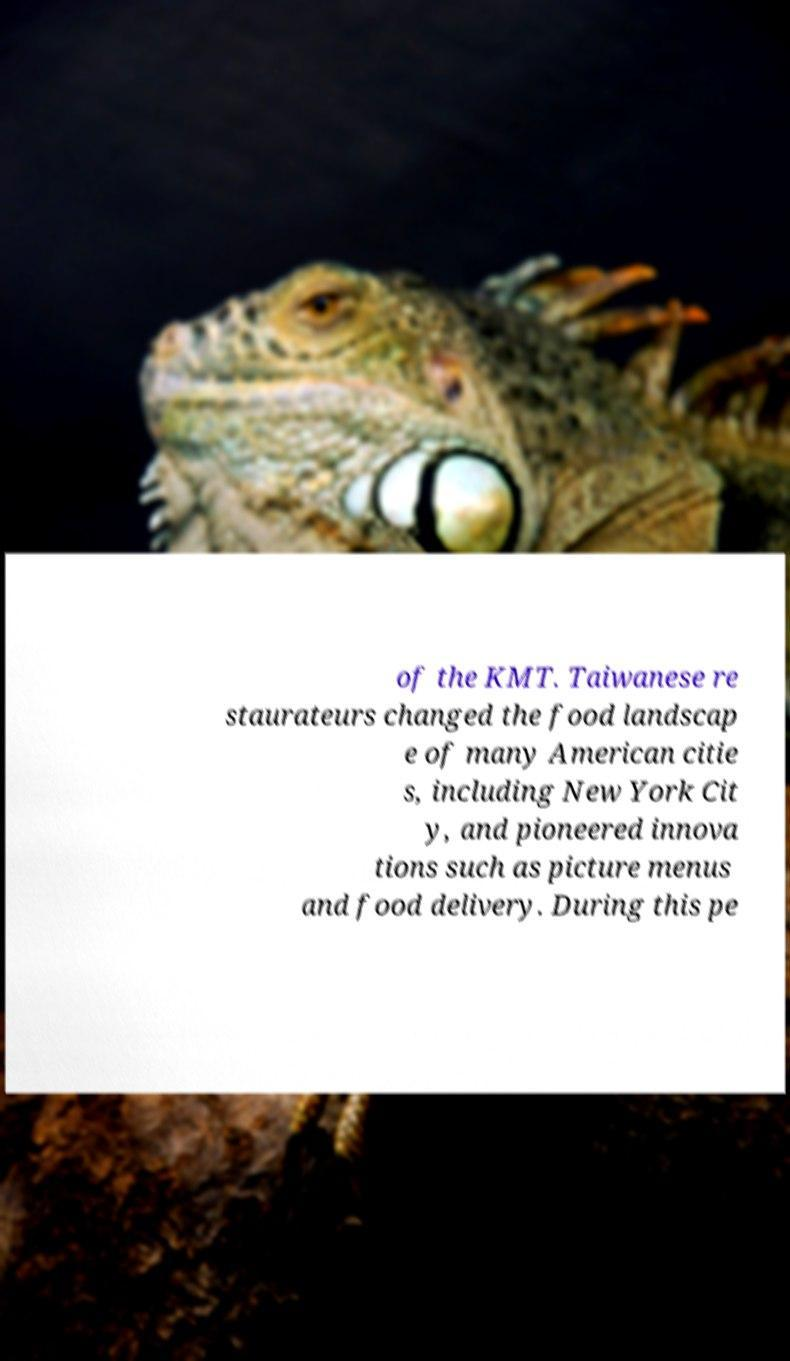There's text embedded in this image that I need extracted. Can you transcribe it verbatim? of the KMT. Taiwanese re staurateurs changed the food landscap e of many American citie s, including New York Cit y, and pioneered innova tions such as picture menus and food delivery. During this pe 